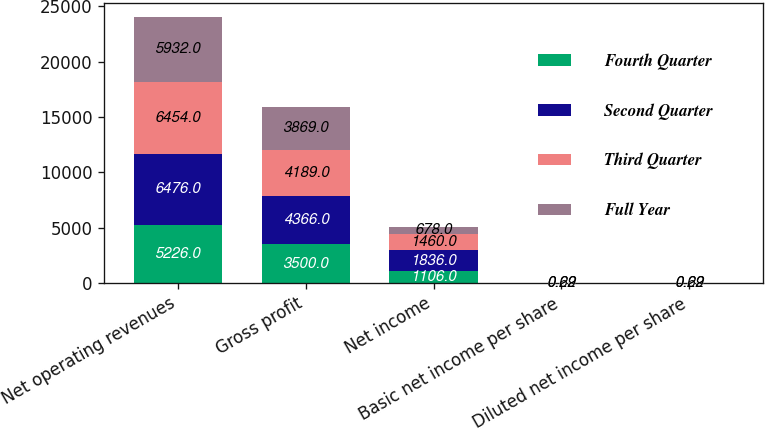<chart> <loc_0><loc_0><loc_500><loc_500><stacked_bar_chart><ecel><fcel>Net operating revenues<fcel>Gross profit<fcel>Net income<fcel>Basic net income per share<fcel>Diluted net income per share<nl><fcel>Fourth Quarter<fcel>5226<fcel>3500<fcel>1106<fcel>0.47<fcel>0.47<nl><fcel>Second Quarter<fcel>6476<fcel>4366<fcel>1836<fcel>0.78<fcel>0.78<nl><fcel>Third Quarter<fcel>6454<fcel>4189<fcel>1460<fcel>0.62<fcel>0.62<nl><fcel>Full Year<fcel>5932<fcel>3869<fcel>678<fcel>0.29<fcel>0.29<nl></chart> 